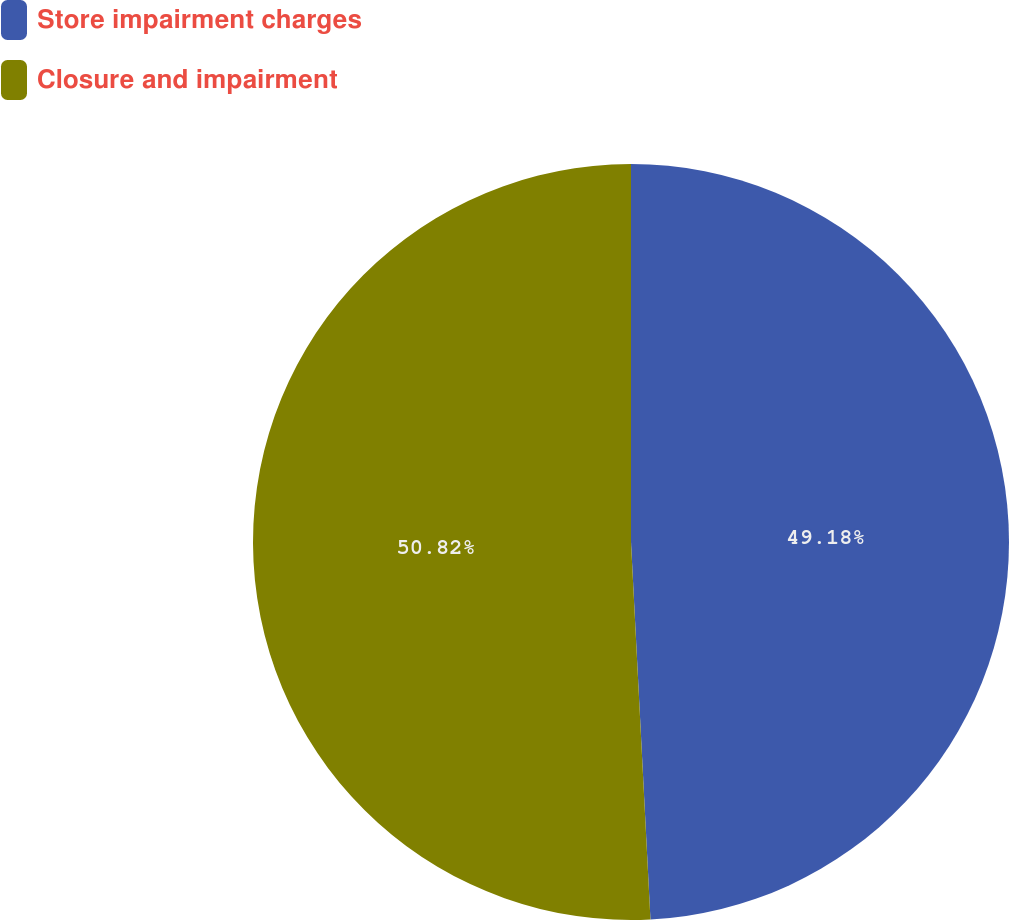Convert chart to OTSL. <chart><loc_0><loc_0><loc_500><loc_500><pie_chart><fcel>Store impairment charges<fcel>Closure and impairment<nl><fcel>49.18%<fcel>50.82%<nl></chart> 